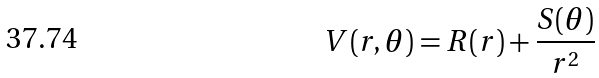<formula> <loc_0><loc_0><loc_500><loc_500>V ( r , \theta ) = R ( r ) + \frac { S ( \theta ) } { r ^ { 2 } }</formula> 